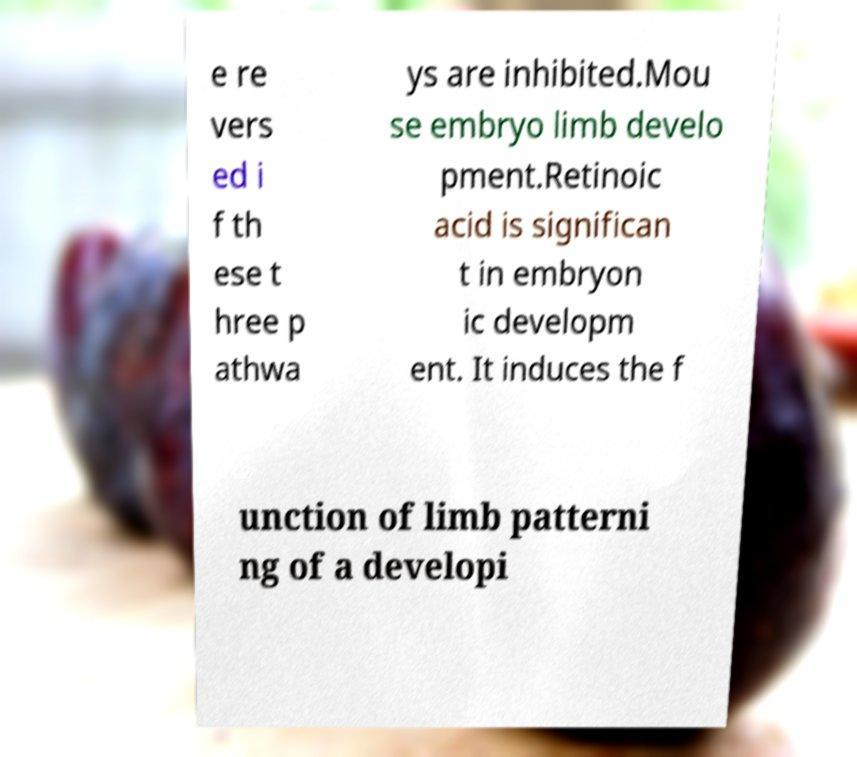Can you accurately transcribe the text from the provided image for me? e re vers ed i f th ese t hree p athwa ys are inhibited.Mou se embryo limb develo pment.Retinoic acid is significan t in embryon ic developm ent. It induces the f unction of limb patterni ng of a developi 